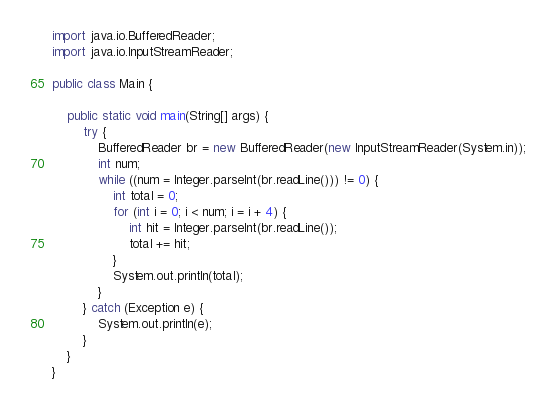Convert code to text. <code><loc_0><loc_0><loc_500><loc_500><_Java_>import java.io.BufferedReader;
import java.io.InputStreamReader;

public class Main {

	public static void main(String[] args) {
		try {
			BufferedReader br = new BufferedReader(new InputStreamReader(System.in));
			int num;
			while ((num = Integer.parseInt(br.readLine())) != 0) {
				int total = 0;
				for (int i = 0; i < num; i = i + 4) {
					int hit = Integer.parseInt(br.readLine());
					total += hit;
				}
				System.out.println(total);
			}
		} catch (Exception e) {
			System.out.println(e);
		}
	}
}

</code> 